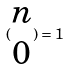<formula> <loc_0><loc_0><loc_500><loc_500>( \begin{matrix} n \\ 0 \end{matrix} ) = 1</formula> 